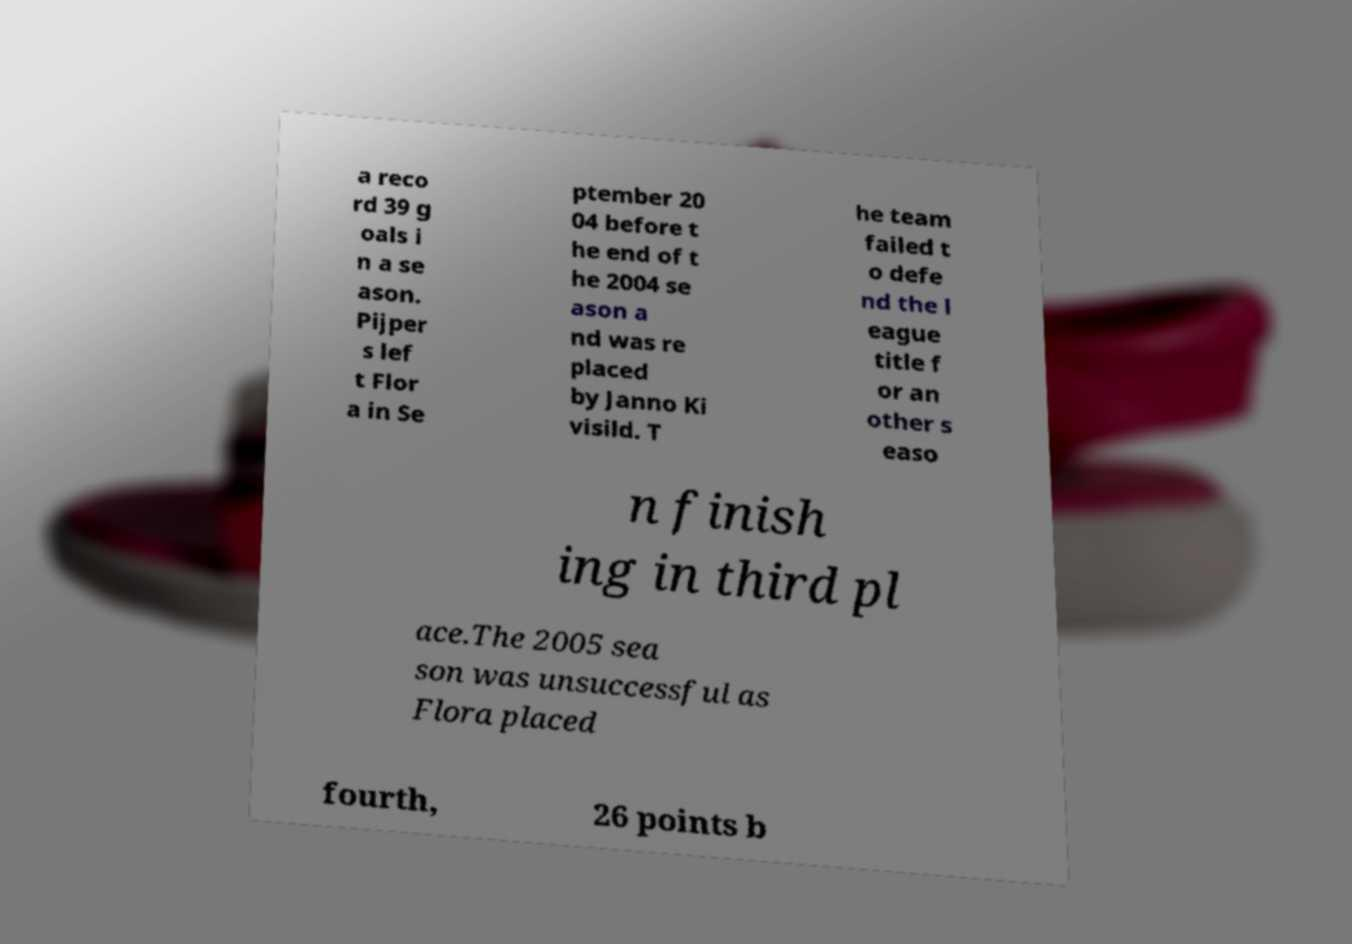Could you assist in decoding the text presented in this image and type it out clearly? a reco rd 39 g oals i n a se ason. Pijper s lef t Flor a in Se ptember 20 04 before t he end of t he 2004 se ason a nd was re placed by Janno Ki visild. T he team failed t o defe nd the l eague title f or an other s easo n finish ing in third pl ace.The 2005 sea son was unsuccessful as Flora placed fourth, 26 points b 